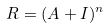<formula> <loc_0><loc_0><loc_500><loc_500>R = ( A + I ) ^ { n }</formula> 